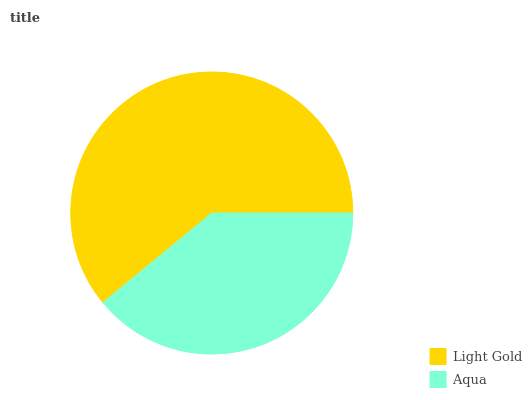Is Aqua the minimum?
Answer yes or no. Yes. Is Light Gold the maximum?
Answer yes or no. Yes. Is Aqua the maximum?
Answer yes or no. No. Is Light Gold greater than Aqua?
Answer yes or no. Yes. Is Aqua less than Light Gold?
Answer yes or no. Yes. Is Aqua greater than Light Gold?
Answer yes or no. No. Is Light Gold less than Aqua?
Answer yes or no. No. Is Light Gold the high median?
Answer yes or no. Yes. Is Aqua the low median?
Answer yes or no. Yes. Is Aqua the high median?
Answer yes or no. No. Is Light Gold the low median?
Answer yes or no. No. 